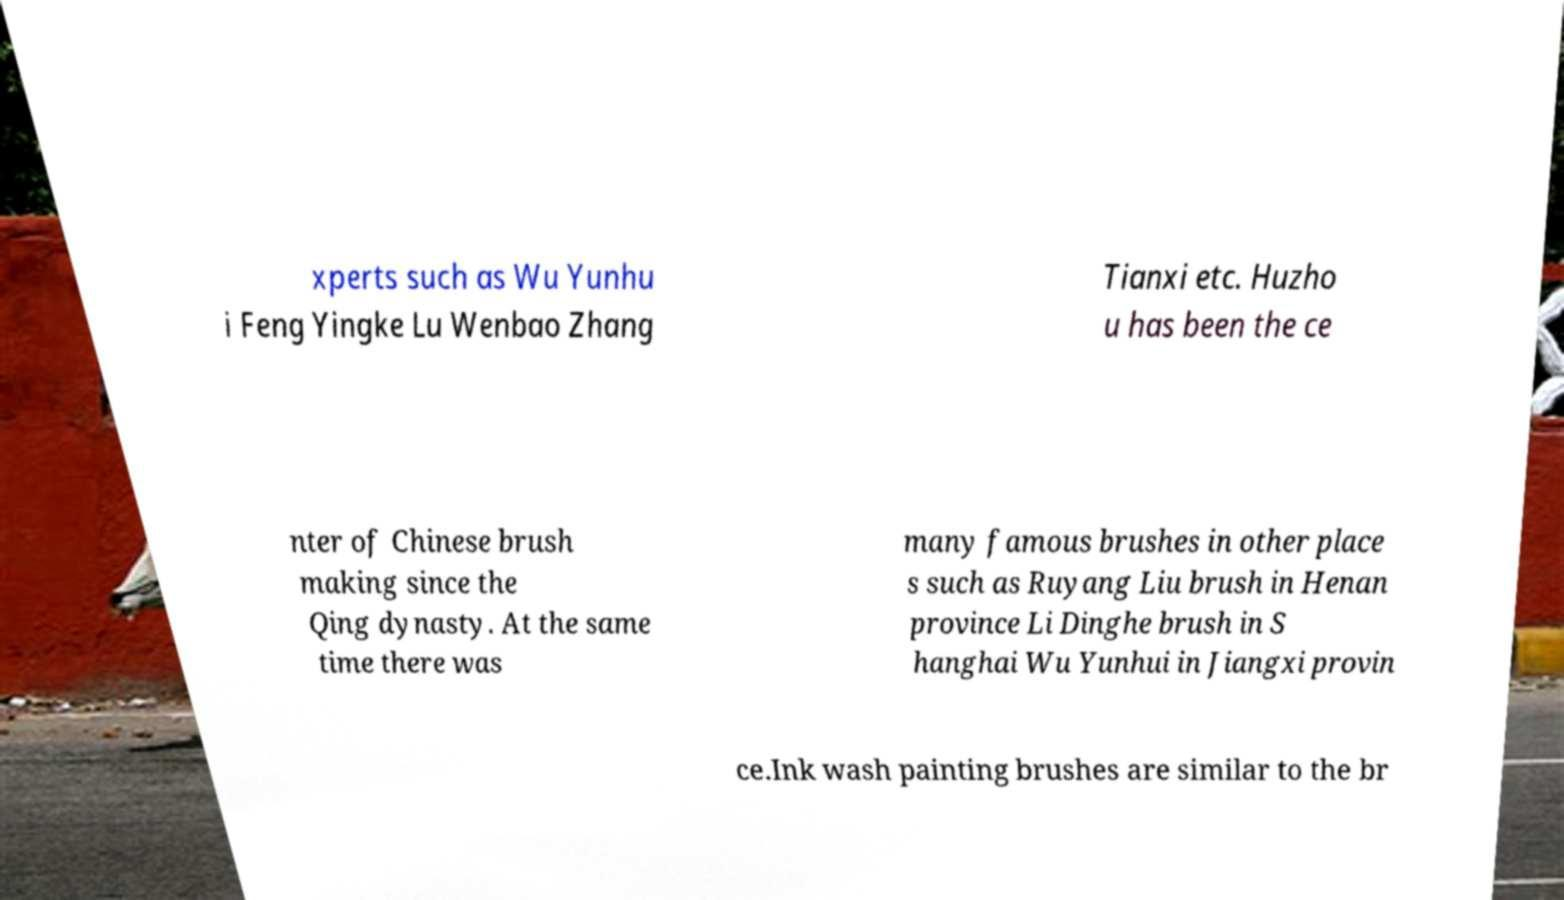Please identify and transcribe the text found in this image. xperts such as Wu Yunhu i Feng Yingke Lu Wenbao Zhang Tianxi etc. Huzho u has been the ce nter of Chinese brush making since the Qing dynasty. At the same time there was many famous brushes in other place s such as Ruyang Liu brush in Henan province Li Dinghe brush in S hanghai Wu Yunhui in Jiangxi provin ce.Ink wash painting brushes are similar to the br 